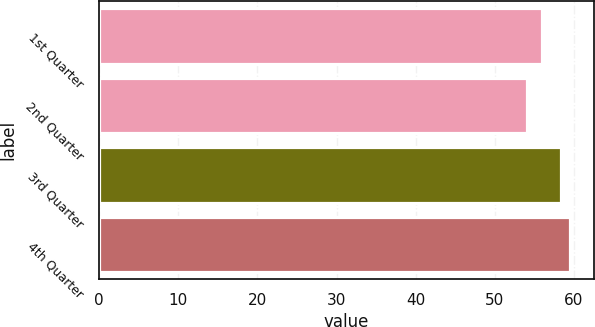Convert chart. <chart><loc_0><loc_0><loc_500><loc_500><bar_chart><fcel>1st Quarter<fcel>2nd Quarter<fcel>3rd Quarter<fcel>4th Quarter<nl><fcel>55.93<fcel>54.08<fcel>58.4<fcel>59.53<nl></chart> 